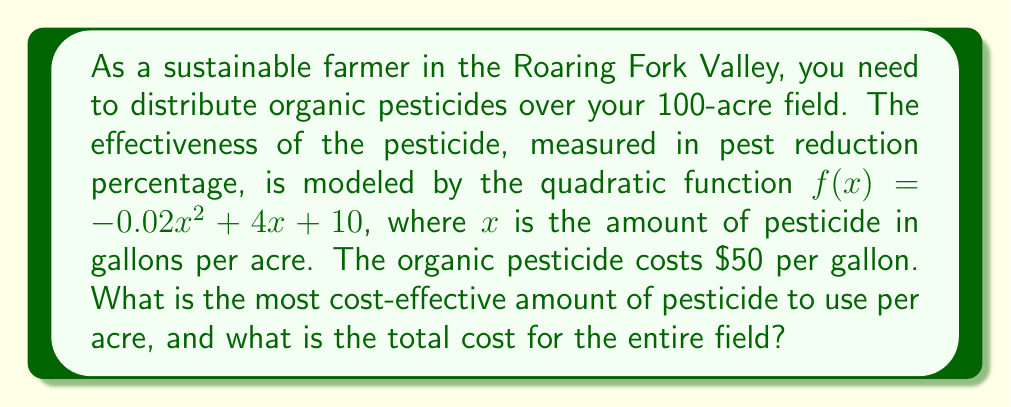Give your solution to this math problem. 1) To find the most cost-effective amount, we need to maximize the effectiveness function:
   $f(x) = -0.02x^2 + 4x + 10$

2) The maximum of a quadratic function occurs at the vertex. For a quadratic in the form $ax^2 + bx + c$, the x-coordinate of the vertex is given by $x = -\frac{b}{2a}$

3) In our function, $a = -0.02$ and $b = 4$. So:
   $x = -\frac{4}{2(-0.02)} = -\frac{4}{-0.04} = 100$

4) Therefore, the most cost-effective amount is 100 gallons per acre.

5) To calculate the total cost:
   - Cost per acre = 100 gallons × $50/gallon = $5,000
   - Total field size = 100 acres
   - Total cost = $5,000/acre × 100 acres = $500,000
Answer: 100 gallons per acre; $500,000 total cost 